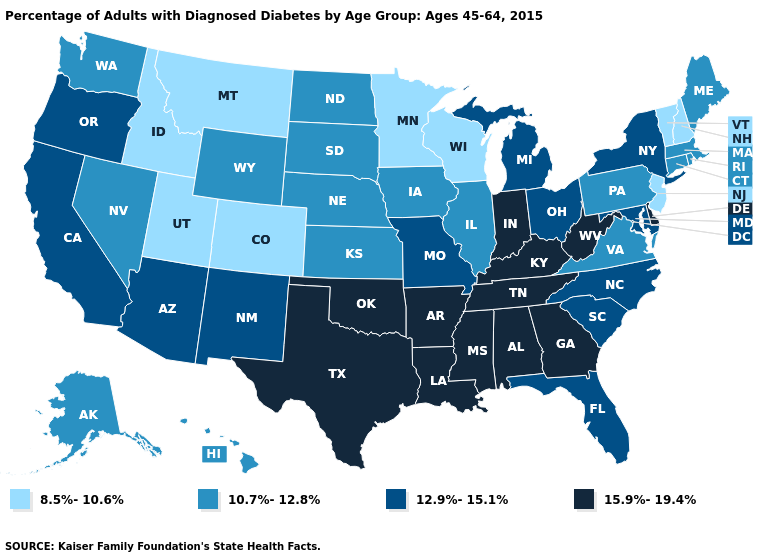Does Minnesota have the lowest value in the USA?
Short answer required. Yes. Does Indiana have the highest value in the MidWest?
Short answer required. Yes. Does West Virginia have the lowest value in the South?
Be succinct. No. Does the map have missing data?
Short answer required. No. What is the highest value in the USA?
Give a very brief answer. 15.9%-19.4%. Name the states that have a value in the range 10.7%-12.8%?
Concise answer only. Alaska, Connecticut, Hawaii, Illinois, Iowa, Kansas, Maine, Massachusetts, Nebraska, Nevada, North Dakota, Pennsylvania, Rhode Island, South Dakota, Virginia, Washington, Wyoming. What is the value of Missouri?
Write a very short answer. 12.9%-15.1%. What is the value of Ohio?
Quick response, please. 12.9%-15.1%. What is the highest value in states that border Oregon?
Short answer required. 12.9%-15.1%. Does the map have missing data?
Write a very short answer. No. Name the states that have a value in the range 8.5%-10.6%?
Quick response, please. Colorado, Idaho, Minnesota, Montana, New Hampshire, New Jersey, Utah, Vermont, Wisconsin. Does Georgia have the highest value in the USA?
Be succinct. Yes. Is the legend a continuous bar?
Write a very short answer. No. What is the lowest value in states that border Michigan?
Concise answer only. 8.5%-10.6%. What is the highest value in the MidWest ?
Answer briefly. 15.9%-19.4%. 